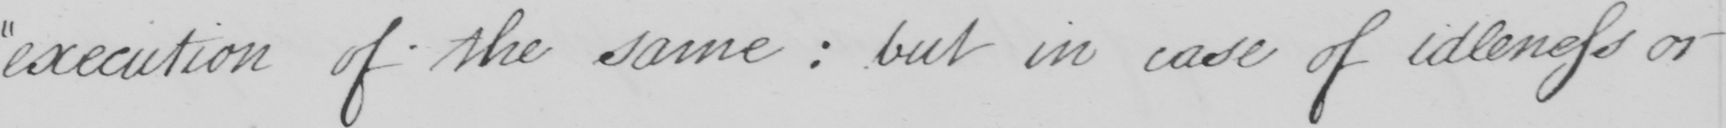Can you read and transcribe this handwriting? execution of the same :  but in case of idleness or 